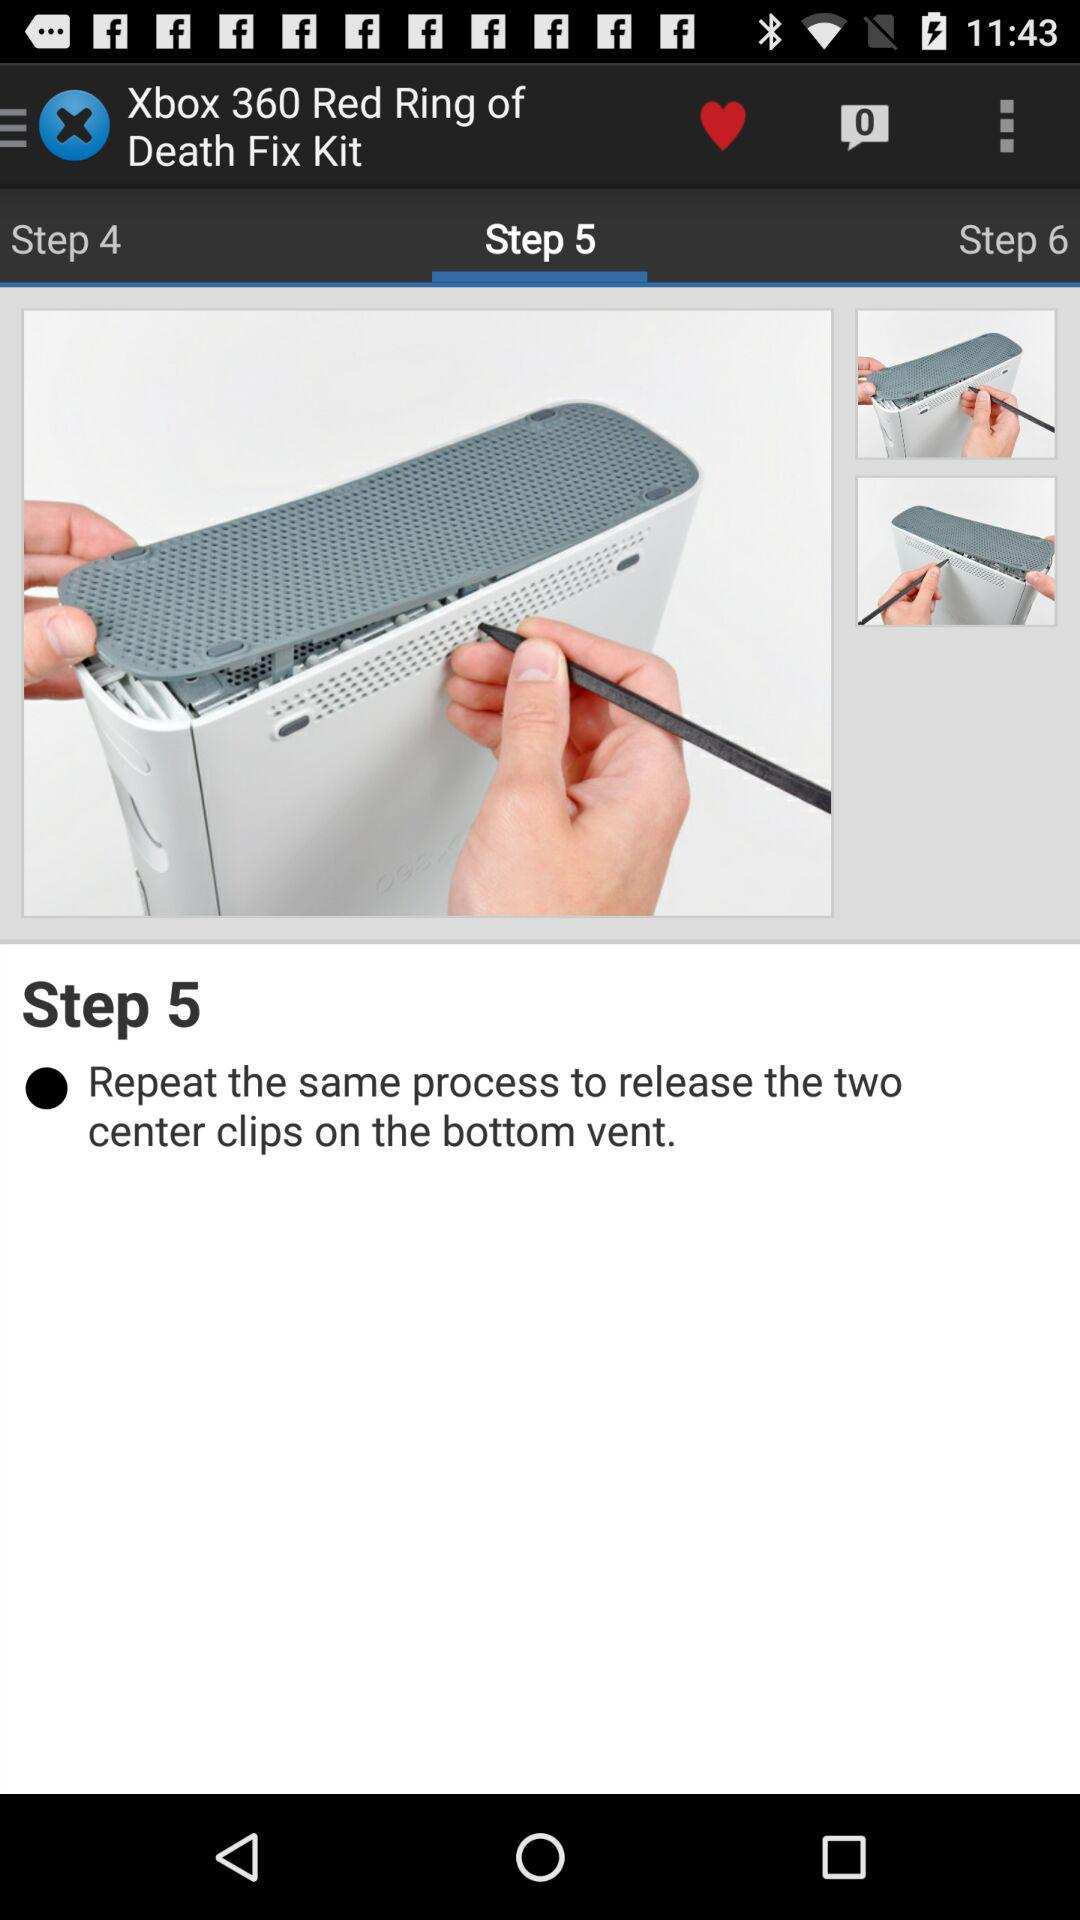How many steps are there in this tutorial?
Answer the question using a single word or phrase. 6 